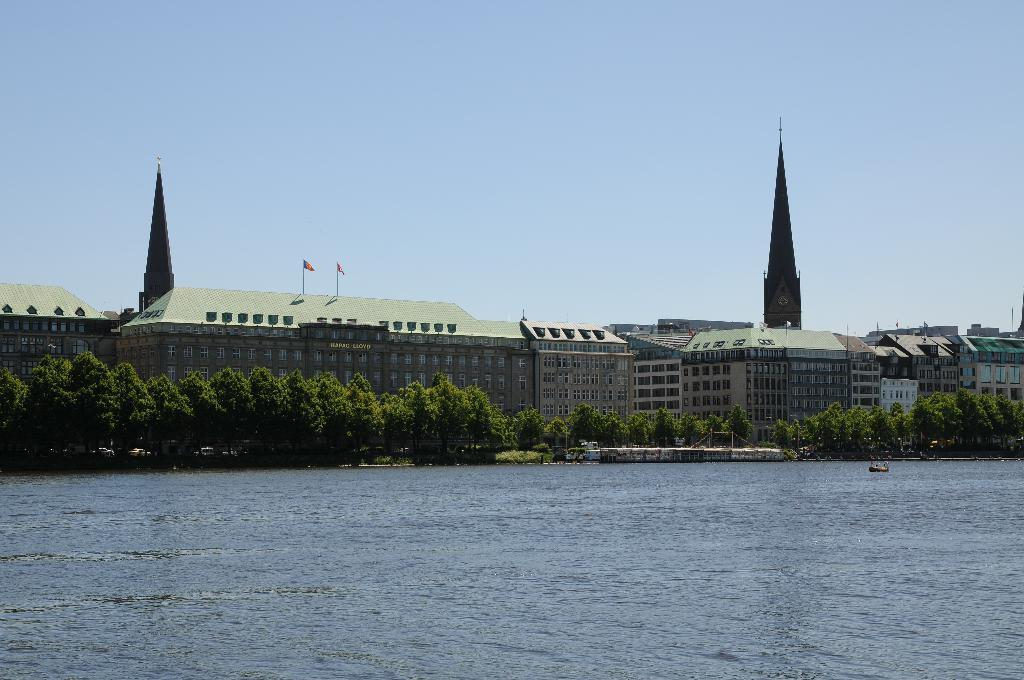What is visible in the image? Water is visible in the image. What can be seen in the background of the image? There are trees, buildings, towers, flags, and the sky visible in the background of the image. How many types of structures can be seen in the background of the image? There are three types of structures visible in the background: buildings, towers, and flags. How does the snake stretch in the image? There is no snake present in the image, so it cannot be stretched or observed. 